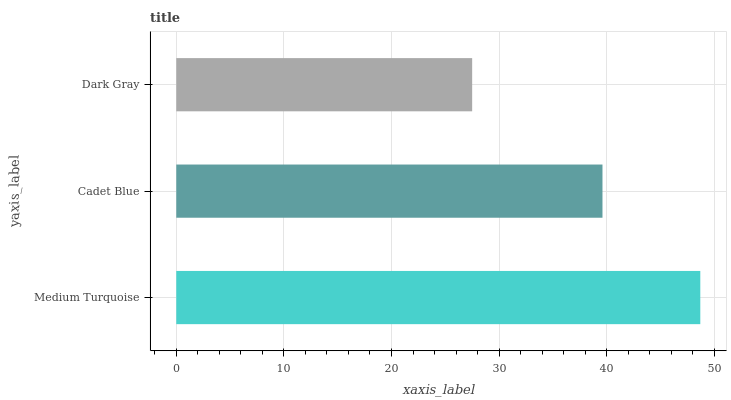Is Dark Gray the minimum?
Answer yes or no. Yes. Is Medium Turquoise the maximum?
Answer yes or no. Yes. Is Cadet Blue the minimum?
Answer yes or no. No. Is Cadet Blue the maximum?
Answer yes or no. No. Is Medium Turquoise greater than Cadet Blue?
Answer yes or no. Yes. Is Cadet Blue less than Medium Turquoise?
Answer yes or no. Yes. Is Cadet Blue greater than Medium Turquoise?
Answer yes or no. No. Is Medium Turquoise less than Cadet Blue?
Answer yes or no. No. Is Cadet Blue the high median?
Answer yes or no. Yes. Is Cadet Blue the low median?
Answer yes or no. Yes. Is Dark Gray the high median?
Answer yes or no. No. Is Medium Turquoise the low median?
Answer yes or no. No. 